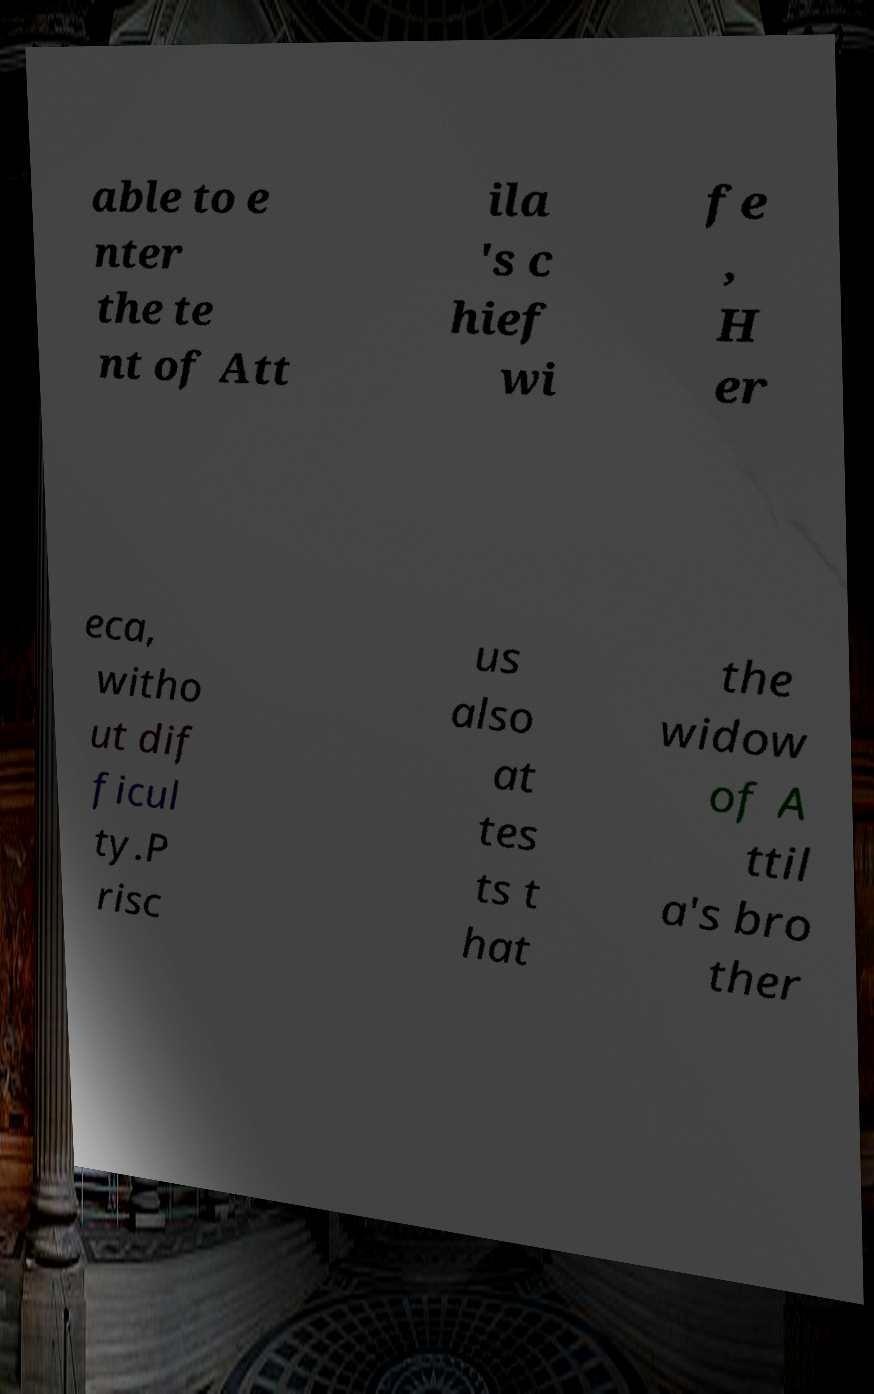Please identify and transcribe the text found in this image. able to e nter the te nt of Att ila 's c hief wi fe , H er eca, witho ut dif ficul ty.P risc us also at tes ts t hat the widow of A ttil a's bro ther 